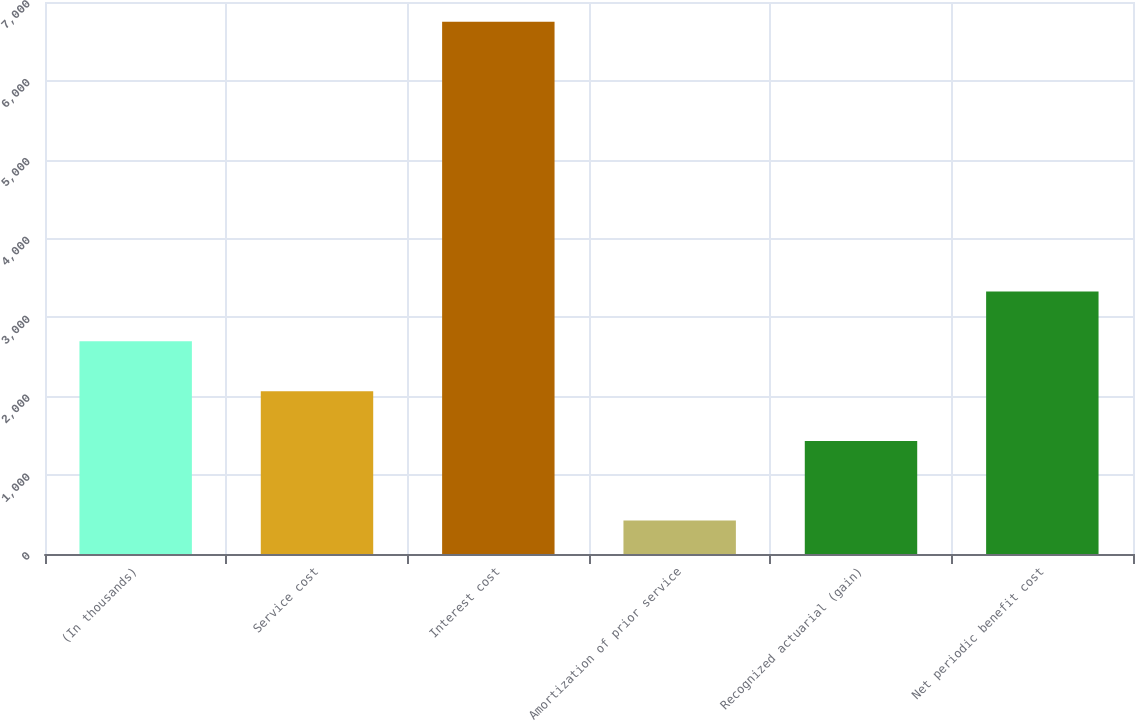Convert chart. <chart><loc_0><loc_0><loc_500><loc_500><bar_chart><fcel>(In thousands)<fcel>Service cost<fcel>Interest cost<fcel>Amortization of prior service<fcel>Recognized actuarial (gain)<fcel>Net periodic benefit cost<nl><fcel>2696.6<fcel>2064.3<fcel>6749<fcel>426<fcel>1432<fcel>3328.9<nl></chart> 